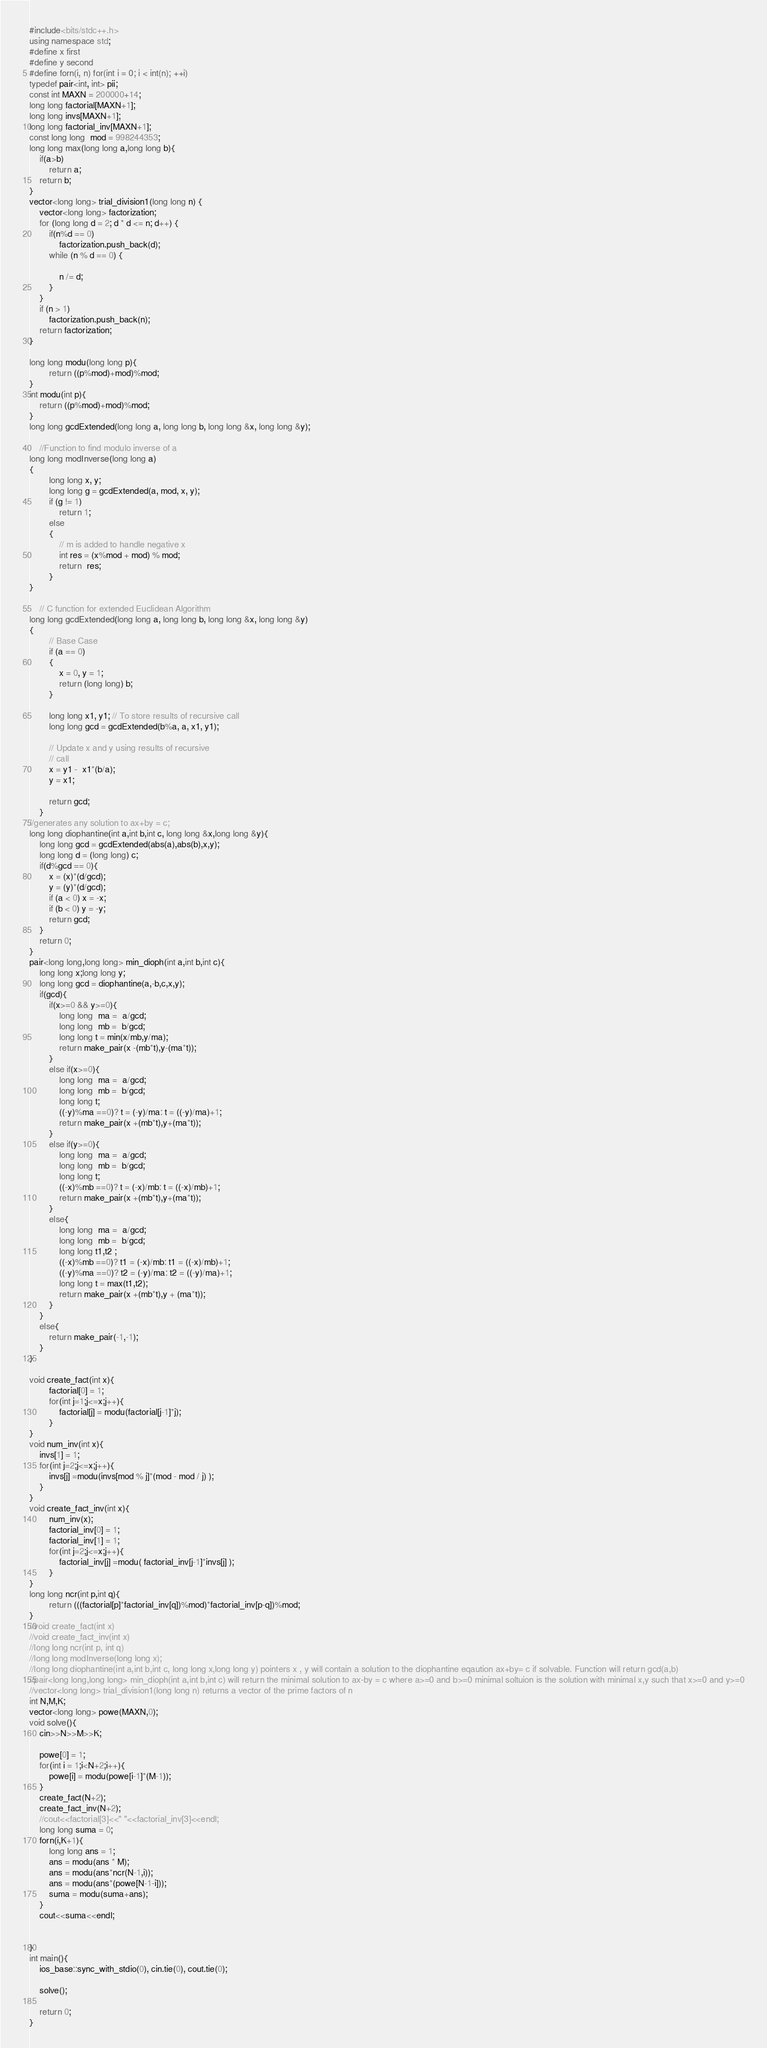<code> <loc_0><loc_0><loc_500><loc_500><_C++_>#include<bits/stdc++.h> 
using namespace std; 
#define x first
#define y second
#define forn(i, n) for(int i = 0; i < int(n); ++i)
typedef pair<int, int> pii;
const int MAXN = 200000+14;
long long factorial[MAXN+1];
long long invs[MAXN+1];
long long factorial_inv[MAXN+1];
const long long  mod = 998244353;
long long max(long long a,long long b){
	if(a>b)
		return a;
	return b;
}
vector<long long> trial_division1(long long n) {
    vector<long long> factorization;
    for (long long d = 2; d * d <= n; d++) {
    	if(n%d == 0)
    		factorization.push_back(d);
        while (n % d == 0) {
            
            n /= d;
        }
    }
    if (n > 1)
        factorization.push_back(n);
    return factorization;
}

long long modu(long long p){
		return ((p%mod)+mod)%mod;
}
int modu(int p){
	return ((p%mod)+mod)%mod;
}
long long gcdExtended(long long a, long long b, long long &x, long long &y); 

	//Function to find modulo inverse of a 
long long modInverse(long long a) 
{ 
	    long long x, y; 
	    long long g = gcdExtended(a, mod, x, y); 
	    if (g != 1) 
	        return 1; 
	    else
	    { 
	        // m is added to handle negative x 
	        int res = (x%mod + mod) % mod; 
	        return  res; 
	    } 
} 
	  
	// C function for extended Euclidean Algorithm 
long long gcdExtended(long long a, long long b, long long &x, long long &y) 
{ 
	    // Base Case 
	    if (a == 0) 
	    { 
	        x = 0, y = 1; 
	        return (long long) b; 
	    } 
	  
	    long long x1, y1; // To store results of recursive call 
	    long long gcd = gcdExtended(b%a, a, x1, y1); 
	  
	    // Update x and y using results of recursive 
	    // call 
	    x = y1 -  x1*(b/a); 
	    y = x1; 
	  
	    return gcd; 
	} 
//generates any solution to ax+by = c;
long long diophantine(int a,int b,int c, long long &x,long long &y){
	long long gcd = gcdExtended(abs(a),abs(b),x,y);
	long long d = (long long) c;
	if(d%gcd == 0){
		x = (x)*(d/gcd);
		y = (y)*(d/gcd);
		if (a < 0) x = -x;
        if (b < 0) y = -y;
		return gcd;
	}
	return 0;
}
pair<long long,long long> min_dioph(int a,int b,int c){
	long long x;long long y;
	long long gcd = diophantine(a,-b,c,x,y);
	if(gcd){
		if(x>=0 && y>=0){
			long long  ma =  a/gcd;
			long long  mb =  b/gcd;
			long long t = min(x/mb,y/ma);
			return make_pair(x -(mb*t),y-(ma*t));
		}
		else if(x>=0){
			long long  ma =  a/gcd;
			long long  mb =  b/gcd;
			long long t;
			((-y)%ma ==0)? t = (-y)/ma: t = ((-y)/ma)+1;
			return make_pair(x +(mb*t),y+(ma*t));
		}
		else if(y>=0){
			long long  ma =  a/gcd;
			long long  mb =  b/gcd;
			long long t;
			((-x)%mb ==0)? t = (-x)/mb: t = ((-x)/mb)+1;
			return make_pair(x +(mb*t),y+(ma*t));
		}
		else{
			long long  ma =  a/gcd;
			long long  mb =  b/gcd;
			long long t1,t2 ;
			((-x)%mb ==0)? t1 = (-x)/mb: t1 = ((-x)/mb)+1;
			((-y)%ma ==0)? t2 = (-y)/ma: t2 = ((-y)/ma)+1;
			long long t = max(t1,t2);
			return make_pair(x +(mb*t),y + (ma*t));
		}
	}
	else{
		return make_pair(-1,-1);
	}
}

void create_fact(int x){
		factorial[0] = 1;
		for(int j=1;j<=x;j++){
			factorial[j] = modu(factorial[j-1]*j);
		}
}
void num_inv(int x){
	invs[1] = 1;
	for(int j=2;j<=x;j++){
		invs[j] =modu(invs[mod % j]*(mod - mod / j) );
	}
}
void create_fact_inv(int x){
	    num_inv(x);
		factorial_inv[0] = 1;
		factorial_inv[1] = 1;
		for(int j=2;j<=x;j++){
			factorial_inv[j] =modu( factorial_inv[j-1]*invs[j] );
		}
}
long long ncr(int p,int q){
		return (((factorial[p]*factorial_inv[q])%mod)*factorial_inv[p-q])%mod;
}
//void create_fact(int x)
//void create_fact_inv(int x)
//long long ncr(int p, int q)
//long long modInverse(long long x);
//long long diophantine(int a,int b,int c, long long x,long long y) pointers x , y will contain a solution to the diophantine eqaution ax+by= c if solvable. Function will return gcd(a,b)
//pair<long long,long long> min_dioph(int a,int b,int c) will return the minimal solution to ax-by = c where a>=0 and b>=0 minimal soltuion is the solution with minimal x,y such that x>=0 and y>=0
//vector<long long> trial_division1(long long n) returns a vector of the prime factors of n
int N,M,K;
vector<long long> powe(MAXN,0);
void solve(){
	cin>>N>>M>>K;
	
	powe[0] = 1;
	for(int i = 1;i<N+2;i++){
		powe[i] = modu(powe[i-1]*(M-1));
	}
	create_fact(N+2);
	create_fact_inv(N+2);
	//cout<<factorial[3]<<" "<<factorial_inv[3]<<endl;
	long long suma = 0;
	forn(i,K+1){
		long long ans = 1;
		ans = modu(ans * M);
		ans = modu(ans*ncr(N-1,i));
		ans = modu(ans*(powe[N-1-i]));
		suma = modu(suma+ans);
	}
	cout<<suma<<endl;
	
	
}
int main(){
    ios_base::sync_with_stdio(0), cin.tie(0), cout.tie(0);
	
	solve();
	
	return 0;	
}</code> 